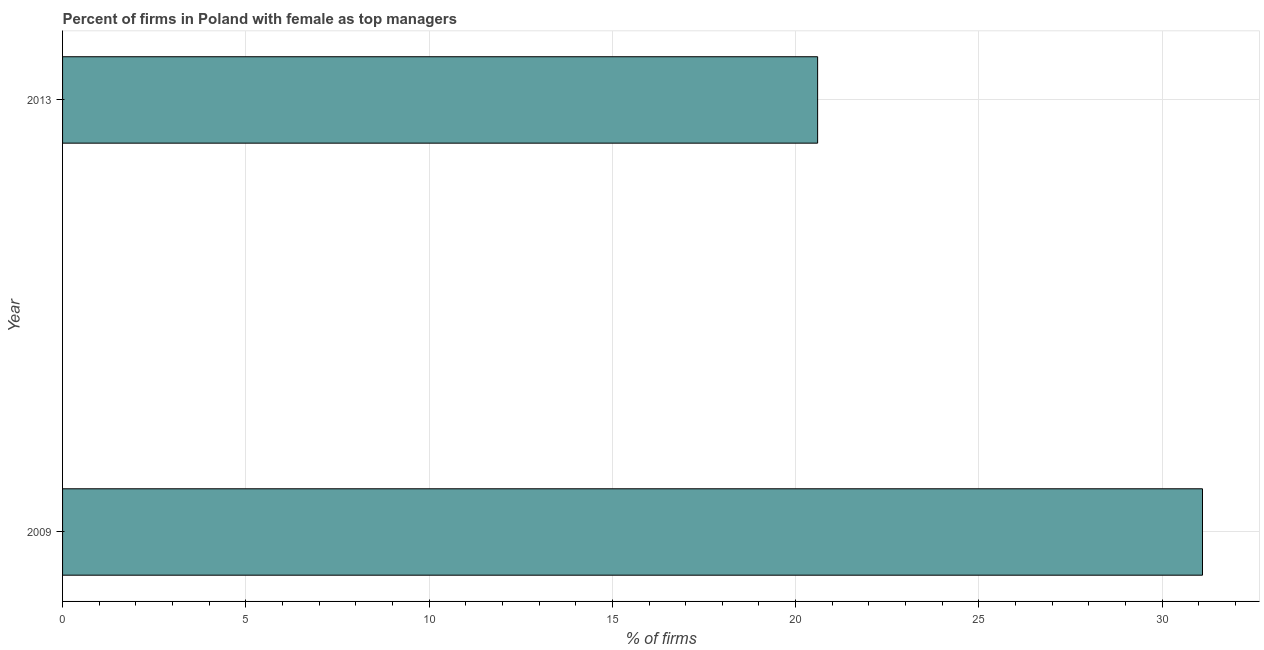Does the graph contain any zero values?
Offer a very short reply. No. What is the title of the graph?
Your response must be concise. Percent of firms in Poland with female as top managers. What is the label or title of the X-axis?
Offer a terse response. % of firms. What is the percentage of firms with female as top manager in 2009?
Give a very brief answer. 31.1. Across all years, what is the maximum percentage of firms with female as top manager?
Provide a short and direct response. 31.1. Across all years, what is the minimum percentage of firms with female as top manager?
Ensure brevity in your answer.  20.6. In which year was the percentage of firms with female as top manager minimum?
Ensure brevity in your answer.  2013. What is the sum of the percentage of firms with female as top manager?
Provide a short and direct response. 51.7. What is the average percentage of firms with female as top manager per year?
Your answer should be compact. 25.85. What is the median percentage of firms with female as top manager?
Provide a succinct answer. 25.85. In how many years, is the percentage of firms with female as top manager greater than 23 %?
Your answer should be very brief. 1. Do a majority of the years between 2009 and 2013 (inclusive) have percentage of firms with female as top manager greater than 21 %?
Your answer should be very brief. No. What is the ratio of the percentage of firms with female as top manager in 2009 to that in 2013?
Make the answer very short. 1.51. What is the difference between two consecutive major ticks on the X-axis?
Your answer should be compact. 5. What is the % of firms in 2009?
Provide a succinct answer. 31.1. What is the % of firms in 2013?
Your response must be concise. 20.6. What is the ratio of the % of firms in 2009 to that in 2013?
Give a very brief answer. 1.51. 